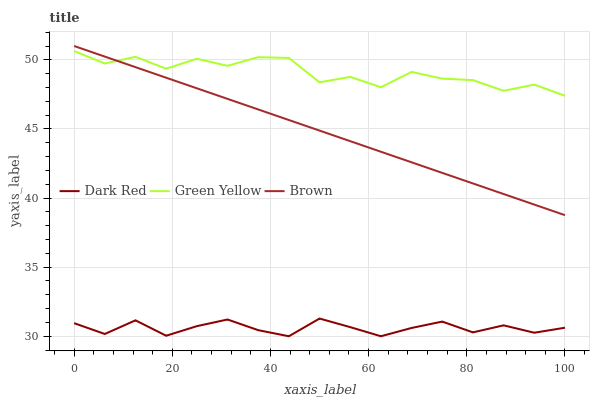Does Brown have the minimum area under the curve?
Answer yes or no. No. Does Brown have the maximum area under the curve?
Answer yes or no. No. Is Green Yellow the smoothest?
Answer yes or no. No. Is Brown the roughest?
Answer yes or no. No. Does Brown have the lowest value?
Answer yes or no. No. Does Green Yellow have the highest value?
Answer yes or no. No. Is Dark Red less than Brown?
Answer yes or no. Yes. Is Brown greater than Dark Red?
Answer yes or no. Yes. Does Dark Red intersect Brown?
Answer yes or no. No. 